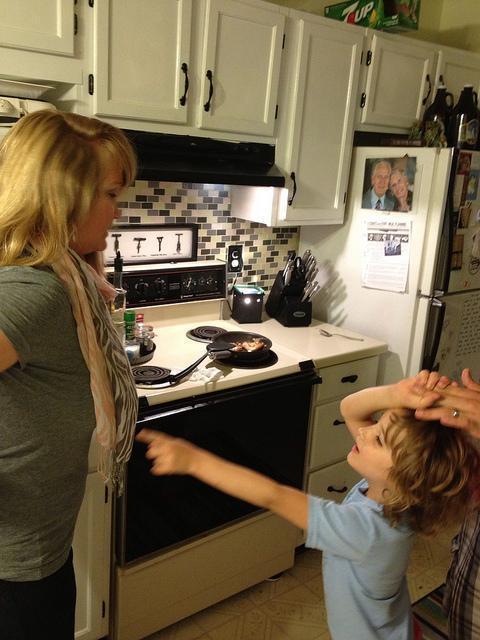How many people are in the picture on side of refrigerator?
Give a very brief answer. 2. How many people can be seen?
Give a very brief answer. 3. How many skateboards are in the picture?
Give a very brief answer. 0. 